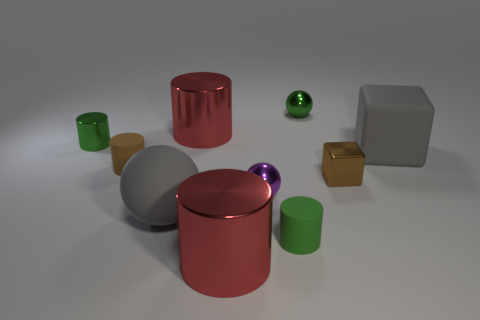What number of other objects are the same shape as the brown rubber object?
Ensure brevity in your answer.  4. There is a gray ball in front of the rubber block; how big is it?
Your answer should be very brief. Large. How many things are right of the large gray object that is right of the tiny block?
Your response must be concise. 0. How many other things are the same size as the brown matte thing?
Offer a terse response. 5. Do the shiny block and the large rubber sphere have the same color?
Keep it short and to the point. No. Is the shape of the green rubber thing that is left of the brown shiny thing the same as  the brown metal object?
Provide a short and direct response. No. How many things are both behind the large rubber sphere and on the right side of the green metal cylinder?
Keep it short and to the point. 6. What is the gray block made of?
Ensure brevity in your answer.  Rubber. Is there any other thing that has the same color as the rubber block?
Provide a succinct answer. Yes. Does the small brown cylinder have the same material as the large ball?
Keep it short and to the point. Yes. 